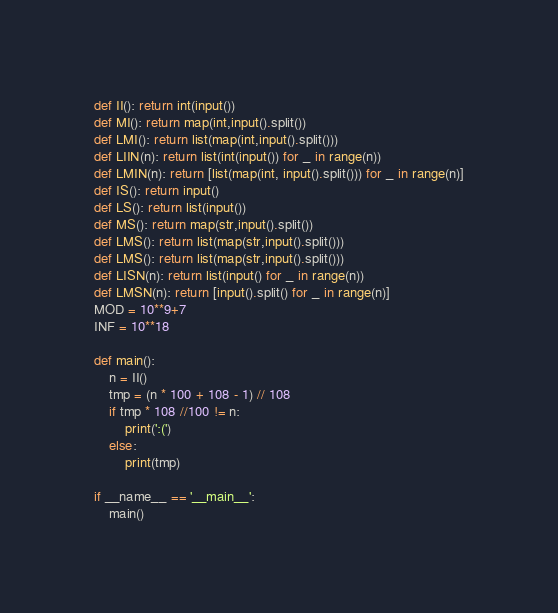<code> <loc_0><loc_0><loc_500><loc_500><_Python_>def II(): return int(input())
def MI(): return map(int,input().split())
def LMI(): return list(map(int,input().split()))
def LIIN(n): return list(int(input()) for _ in range(n))
def LMIN(n): return [list(map(int, input().split())) for _ in range(n)]
def IS(): return input()
def LS(): return list(input())
def MS(): return map(str,input().split())
def LMS(): return list(map(str,input().split()))
def LMS(): return list(map(str,input().split()))
def LISN(n): return list(input() for _ in range(n))
def LMSN(n): return [input().split() for _ in range(n)]
MOD = 10**9+7
INF = 10**18

def main():
    n = II()
    tmp = (n * 100 + 108 - 1) // 108
    if tmp * 108 //100 != n:
        print(':(')
    else:
        print(tmp)

if __name__ == '__main__':
    main()
</code> 